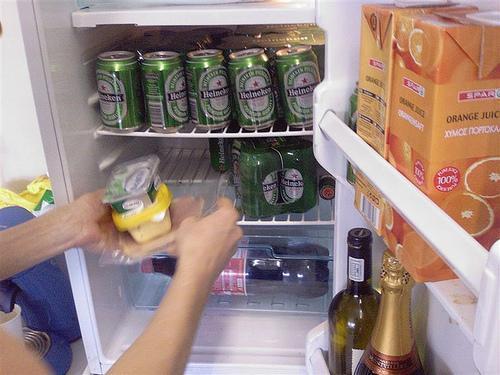How many bottles are in the photo?
Give a very brief answer. 3. 